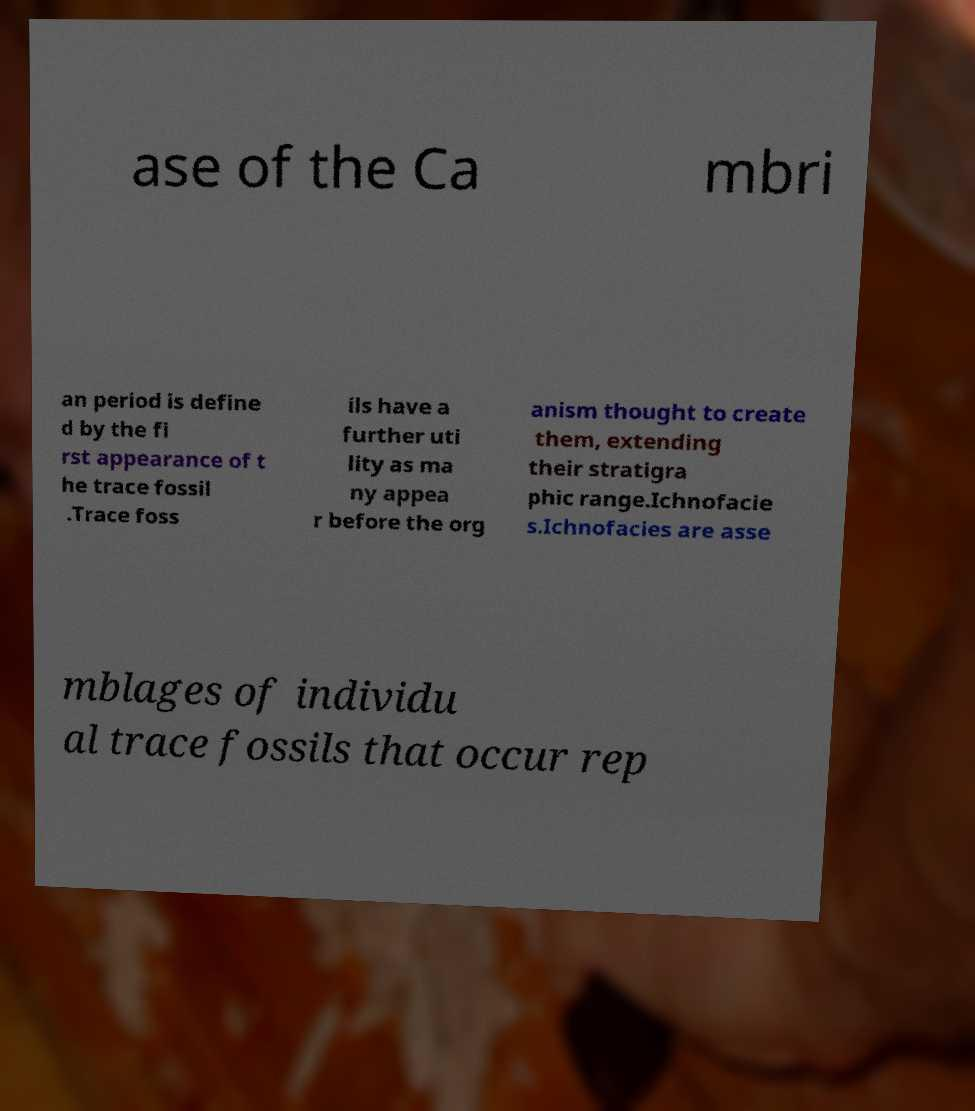Could you assist in decoding the text presented in this image and type it out clearly? ase of the Ca mbri an period is define d by the fi rst appearance of t he trace fossil .Trace foss ils have a further uti lity as ma ny appea r before the org anism thought to create them, extending their stratigra phic range.Ichnofacie s.Ichnofacies are asse mblages of individu al trace fossils that occur rep 